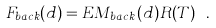<formula> <loc_0><loc_0><loc_500><loc_500>F _ { b a c k } ( d ) = E M _ { b a c k } ( d ) R ( T ) \ .</formula> 